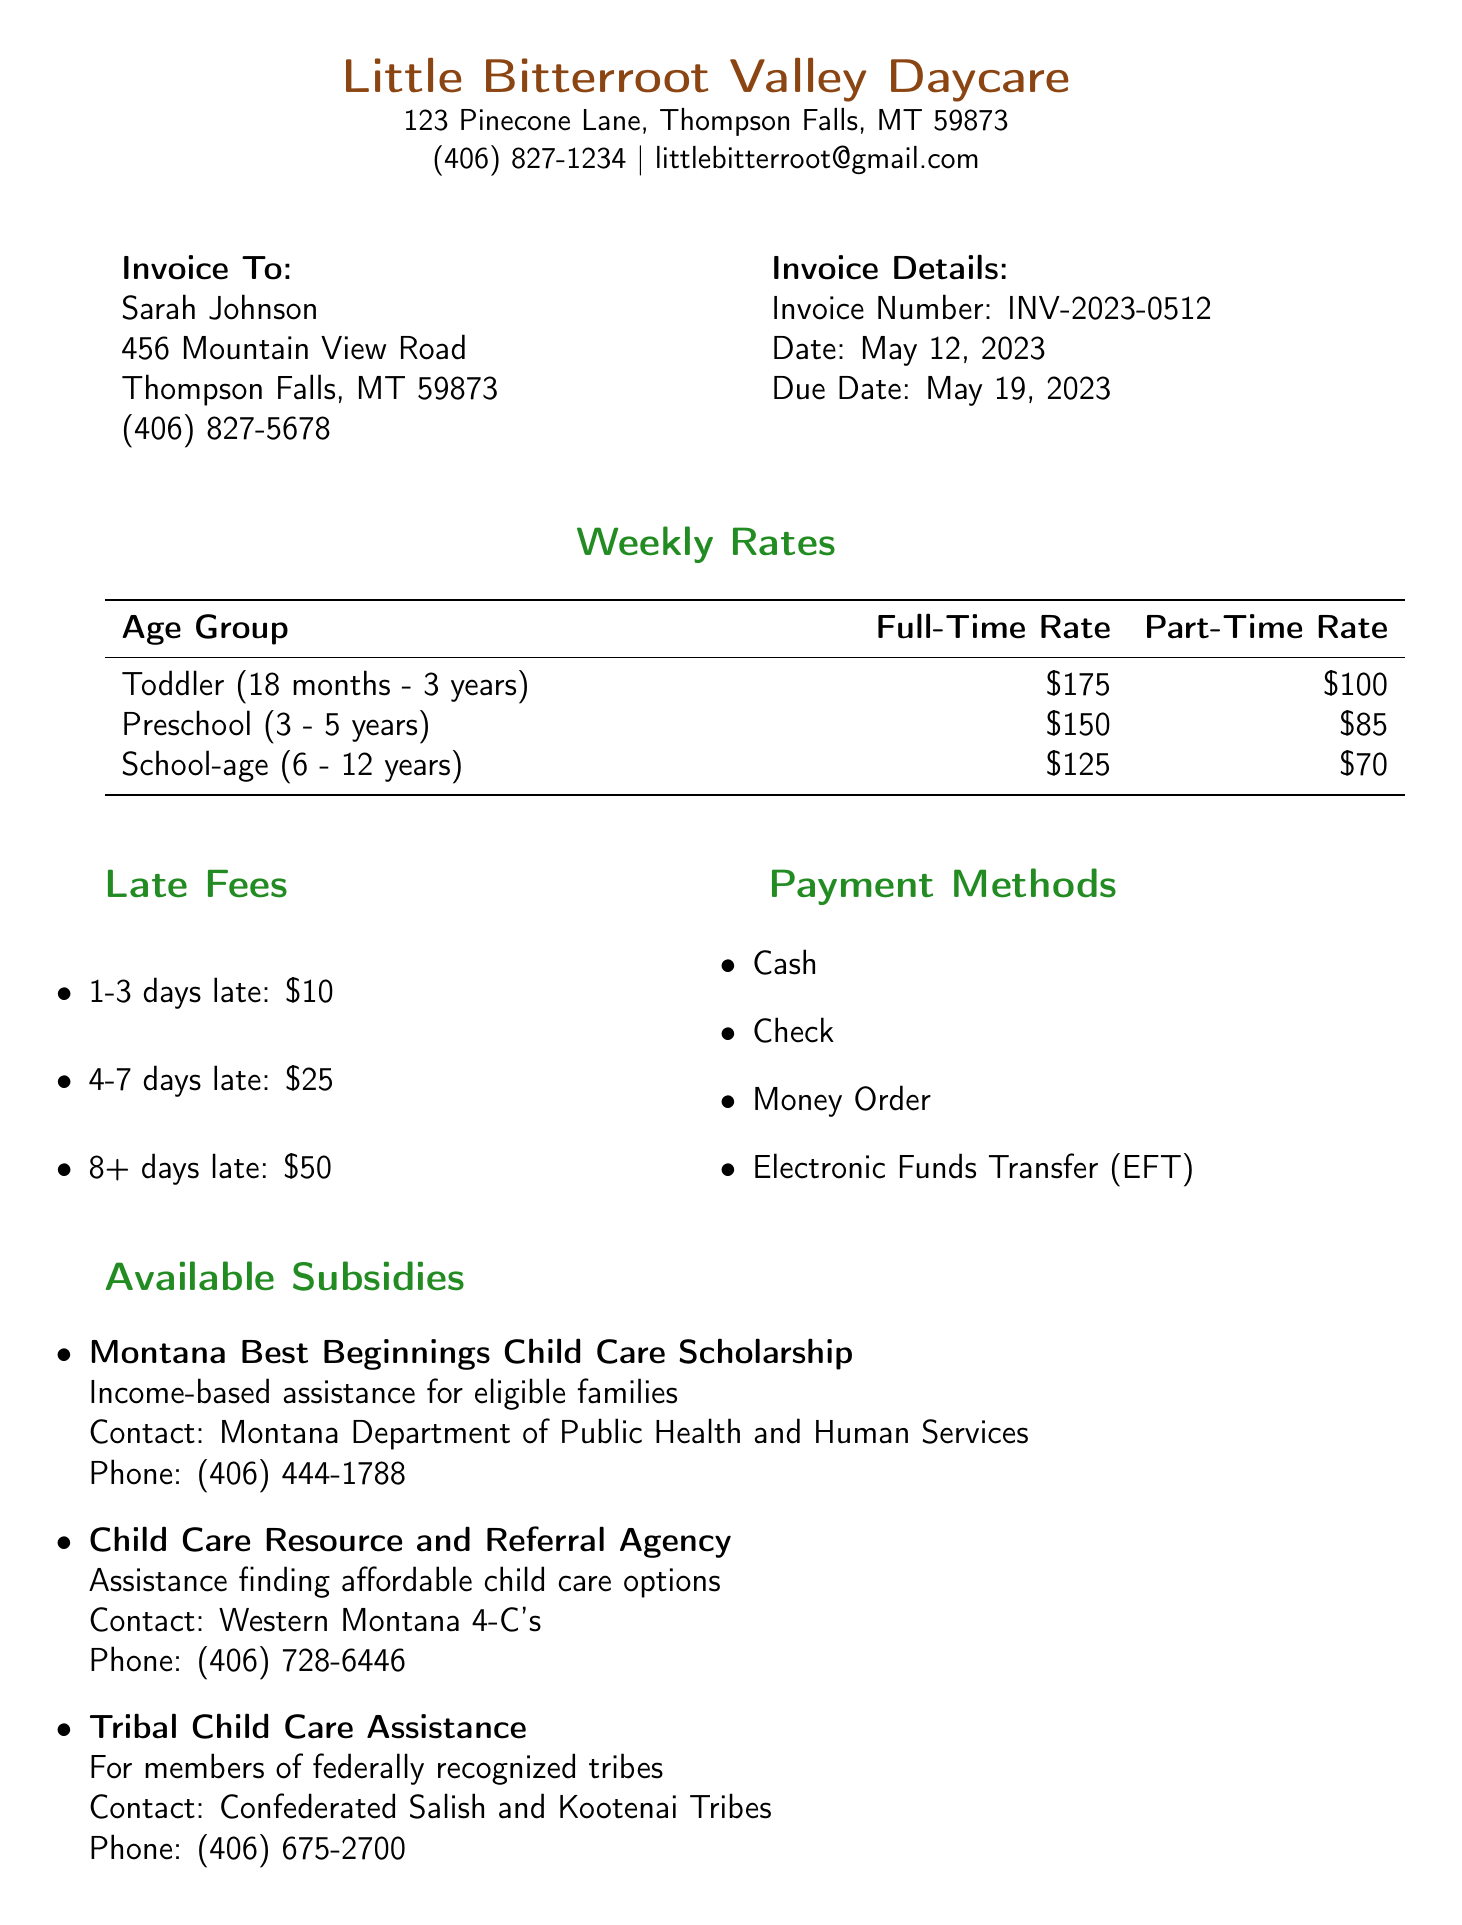What is the business name? The business name is listed at the top of the document.
Answer: Little Bitterroot Valley Daycare What is the full-time rate for preschool children? The full-time rate for preschool children can be found in the weekly rates section.
Answer: $150 When is the invoice due date? The due date is specified in the invoice details.
Answer: May 19, 2023 What is the late fee for being 4-7 days late? The late fees section specifies the fee amount for different late periods.
Answer: $25 What subsidy provides income-based assistance? Available subsidies are listed in a section, one of which is income-based.
Answer: Montana Best Beginnings Child Care Scholarship How much is the late pickup fee? Additional information mentions the late pickup fee amount.
Answer: $1 per minute after 6:00 PM What are the operating hours of the daycare? Operating hours can be found under additional information.
Answer: Monday - Friday, 7:00 AM - 6:00 PM What contact is associated with the Child Care Resource and Referral Agency? Each subsidy provides a contact in its description, which includes one for this agency.
Answer: Western Montana 4-C's What is the phone number for the daycare? The phone number is listed with the business name at the top of the document.
Answer: (406) 827-1234 